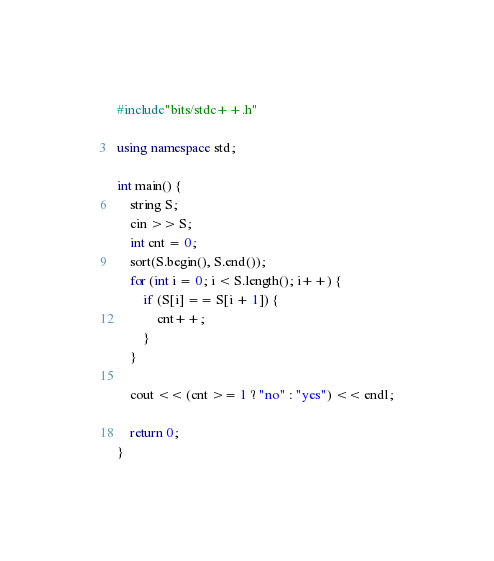<code> <loc_0><loc_0><loc_500><loc_500><_C++_>#include"bits/stdc++.h"

using namespace std;

int main() {
	string S;
	cin >> S;
	int cnt = 0;
	sort(S.begin(), S.end());
	for (int i = 0; i < S.length(); i++) {
		if (S[i] == S[i + 1]) {
			cnt++;
		}
	}

	cout << (cnt >= 1 ? "no" : "yes") << endl;

	return 0;
}</code> 